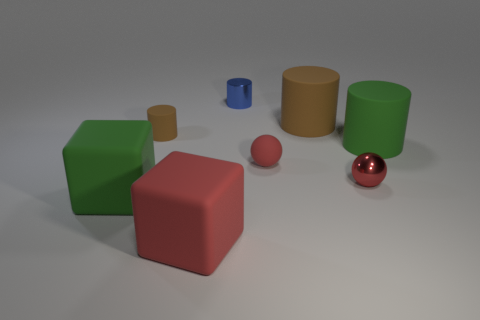Is the number of large green rubber things that are behind the large green rubber cylinder greater than the number of matte objects?
Provide a short and direct response. No. How many small shiny things are behind the tiny metal sphere and in front of the big brown object?
Your answer should be compact. 0. There is a matte object that is on the right side of the metallic object that is in front of the blue cylinder; what color is it?
Keep it short and to the point. Green. How many big cylinders are the same color as the tiny rubber cylinder?
Your answer should be compact. 1. Do the metallic ball and the small matte thing in front of the tiny brown object have the same color?
Offer a very short reply. Yes. Are there fewer gray rubber cylinders than green things?
Offer a terse response. Yes. Are there more big rubber objects that are behind the tiny brown rubber cylinder than brown rubber cylinders that are right of the red metallic object?
Offer a very short reply. Yes. Is the large red thing made of the same material as the small blue object?
Your answer should be compact. No. What number of small red shiny balls are behind the large cube to the left of the small matte cylinder?
Your response must be concise. 1. Does the tiny sphere that is in front of the red matte sphere have the same color as the matte ball?
Offer a very short reply. Yes. 